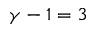<formula> <loc_0><loc_0><loc_500><loc_500>\gamma - 1 = 3</formula> 